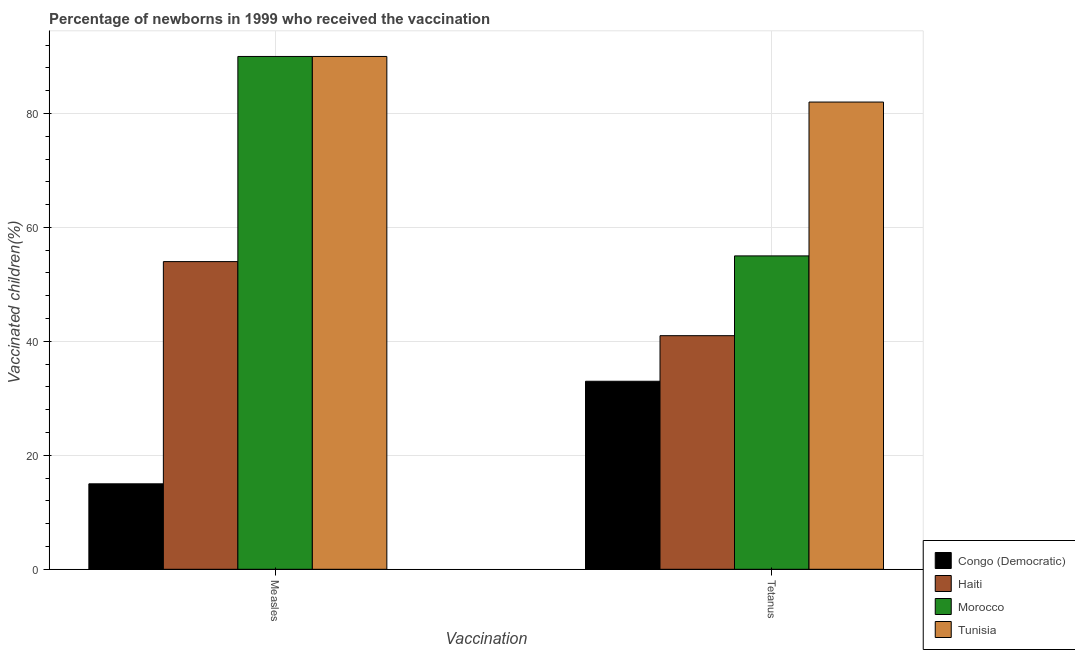Are the number of bars on each tick of the X-axis equal?
Provide a short and direct response. Yes. How many bars are there on the 2nd tick from the left?
Keep it short and to the point. 4. How many bars are there on the 2nd tick from the right?
Provide a succinct answer. 4. What is the label of the 2nd group of bars from the left?
Make the answer very short. Tetanus. What is the percentage of newborns who received vaccination for measles in Tunisia?
Offer a very short reply. 90. Across all countries, what is the maximum percentage of newborns who received vaccination for tetanus?
Provide a short and direct response. 82. Across all countries, what is the minimum percentage of newborns who received vaccination for tetanus?
Offer a terse response. 33. In which country was the percentage of newborns who received vaccination for tetanus maximum?
Provide a succinct answer. Tunisia. In which country was the percentage of newborns who received vaccination for tetanus minimum?
Provide a succinct answer. Congo (Democratic). What is the total percentage of newborns who received vaccination for measles in the graph?
Your answer should be very brief. 249. What is the difference between the percentage of newborns who received vaccination for measles in Haiti and that in Morocco?
Your answer should be compact. -36. What is the difference between the percentage of newborns who received vaccination for tetanus in Congo (Democratic) and the percentage of newborns who received vaccination for measles in Haiti?
Provide a short and direct response. -21. What is the average percentage of newborns who received vaccination for tetanus per country?
Make the answer very short. 52.75. What is the difference between the percentage of newborns who received vaccination for measles and percentage of newborns who received vaccination for tetanus in Congo (Democratic)?
Provide a succinct answer. -18. What is the ratio of the percentage of newborns who received vaccination for measles in Congo (Democratic) to that in Morocco?
Give a very brief answer. 0.17. In how many countries, is the percentage of newborns who received vaccination for measles greater than the average percentage of newborns who received vaccination for measles taken over all countries?
Your response must be concise. 2. What does the 2nd bar from the left in Tetanus represents?
Your response must be concise. Haiti. What does the 3rd bar from the right in Tetanus represents?
Your answer should be compact. Haiti. How many bars are there?
Your response must be concise. 8. Are all the bars in the graph horizontal?
Offer a very short reply. No. How many countries are there in the graph?
Your answer should be compact. 4. What is the difference between two consecutive major ticks on the Y-axis?
Your response must be concise. 20. Are the values on the major ticks of Y-axis written in scientific E-notation?
Keep it short and to the point. No. Does the graph contain any zero values?
Provide a short and direct response. No. Does the graph contain grids?
Your answer should be compact. Yes. How many legend labels are there?
Your answer should be very brief. 4. What is the title of the graph?
Provide a short and direct response. Percentage of newborns in 1999 who received the vaccination. Does "Cayman Islands" appear as one of the legend labels in the graph?
Offer a terse response. No. What is the label or title of the X-axis?
Your answer should be compact. Vaccination. What is the label or title of the Y-axis?
Your answer should be compact. Vaccinated children(%)
. What is the Vaccinated children(%)
 in Congo (Democratic) in Tetanus?
Give a very brief answer. 33. What is the Vaccinated children(%)
 of Morocco in Tetanus?
Provide a succinct answer. 55. Across all Vaccination, what is the maximum Vaccinated children(%)
 in Haiti?
Provide a short and direct response. 54. Across all Vaccination, what is the maximum Vaccinated children(%)
 in Morocco?
Offer a terse response. 90. Across all Vaccination, what is the maximum Vaccinated children(%)
 in Tunisia?
Your answer should be very brief. 90. Across all Vaccination, what is the minimum Vaccinated children(%)
 of Congo (Democratic)?
Your answer should be compact. 15. What is the total Vaccinated children(%)
 in Morocco in the graph?
Your answer should be compact. 145. What is the total Vaccinated children(%)
 in Tunisia in the graph?
Provide a succinct answer. 172. What is the difference between the Vaccinated children(%)
 of Haiti in Measles and that in Tetanus?
Offer a very short reply. 13. What is the difference between the Vaccinated children(%)
 of Morocco in Measles and that in Tetanus?
Make the answer very short. 35. What is the difference between the Vaccinated children(%)
 of Congo (Democratic) in Measles and the Vaccinated children(%)
 of Haiti in Tetanus?
Offer a terse response. -26. What is the difference between the Vaccinated children(%)
 of Congo (Democratic) in Measles and the Vaccinated children(%)
 of Tunisia in Tetanus?
Your response must be concise. -67. What is the difference between the Vaccinated children(%)
 in Haiti in Measles and the Vaccinated children(%)
 in Morocco in Tetanus?
Offer a terse response. -1. What is the difference between the Vaccinated children(%)
 in Haiti in Measles and the Vaccinated children(%)
 in Tunisia in Tetanus?
Provide a succinct answer. -28. What is the difference between the Vaccinated children(%)
 of Morocco in Measles and the Vaccinated children(%)
 of Tunisia in Tetanus?
Give a very brief answer. 8. What is the average Vaccinated children(%)
 of Haiti per Vaccination?
Give a very brief answer. 47.5. What is the average Vaccinated children(%)
 of Morocco per Vaccination?
Your response must be concise. 72.5. What is the average Vaccinated children(%)
 in Tunisia per Vaccination?
Your answer should be very brief. 86. What is the difference between the Vaccinated children(%)
 in Congo (Democratic) and Vaccinated children(%)
 in Haiti in Measles?
Ensure brevity in your answer.  -39. What is the difference between the Vaccinated children(%)
 of Congo (Democratic) and Vaccinated children(%)
 of Morocco in Measles?
Provide a short and direct response. -75. What is the difference between the Vaccinated children(%)
 of Congo (Democratic) and Vaccinated children(%)
 of Tunisia in Measles?
Your response must be concise. -75. What is the difference between the Vaccinated children(%)
 of Haiti and Vaccinated children(%)
 of Morocco in Measles?
Your answer should be very brief. -36. What is the difference between the Vaccinated children(%)
 of Haiti and Vaccinated children(%)
 of Tunisia in Measles?
Make the answer very short. -36. What is the difference between the Vaccinated children(%)
 in Morocco and Vaccinated children(%)
 in Tunisia in Measles?
Offer a terse response. 0. What is the difference between the Vaccinated children(%)
 of Congo (Democratic) and Vaccinated children(%)
 of Morocco in Tetanus?
Your answer should be compact. -22. What is the difference between the Vaccinated children(%)
 of Congo (Democratic) and Vaccinated children(%)
 of Tunisia in Tetanus?
Give a very brief answer. -49. What is the difference between the Vaccinated children(%)
 of Haiti and Vaccinated children(%)
 of Morocco in Tetanus?
Your answer should be compact. -14. What is the difference between the Vaccinated children(%)
 in Haiti and Vaccinated children(%)
 in Tunisia in Tetanus?
Provide a short and direct response. -41. What is the difference between the Vaccinated children(%)
 of Morocco and Vaccinated children(%)
 of Tunisia in Tetanus?
Keep it short and to the point. -27. What is the ratio of the Vaccinated children(%)
 in Congo (Democratic) in Measles to that in Tetanus?
Provide a succinct answer. 0.45. What is the ratio of the Vaccinated children(%)
 of Haiti in Measles to that in Tetanus?
Keep it short and to the point. 1.32. What is the ratio of the Vaccinated children(%)
 in Morocco in Measles to that in Tetanus?
Your response must be concise. 1.64. What is the ratio of the Vaccinated children(%)
 in Tunisia in Measles to that in Tetanus?
Your answer should be very brief. 1.1. What is the difference between the highest and the second highest Vaccinated children(%)
 of Congo (Democratic)?
Give a very brief answer. 18. What is the difference between the highest and the second highest Vaccinated children(%)
 of Haiti?
Provide a succinct answer. 13. What is the difference between the highest and the second highest Vaccinated children(%)
 in Morocco?
Keep it short and to the point. 35. What is the difference between the highest and the lowest Vaccinated children(%)
 of Tunisia?
Make the answer very short. 8. 